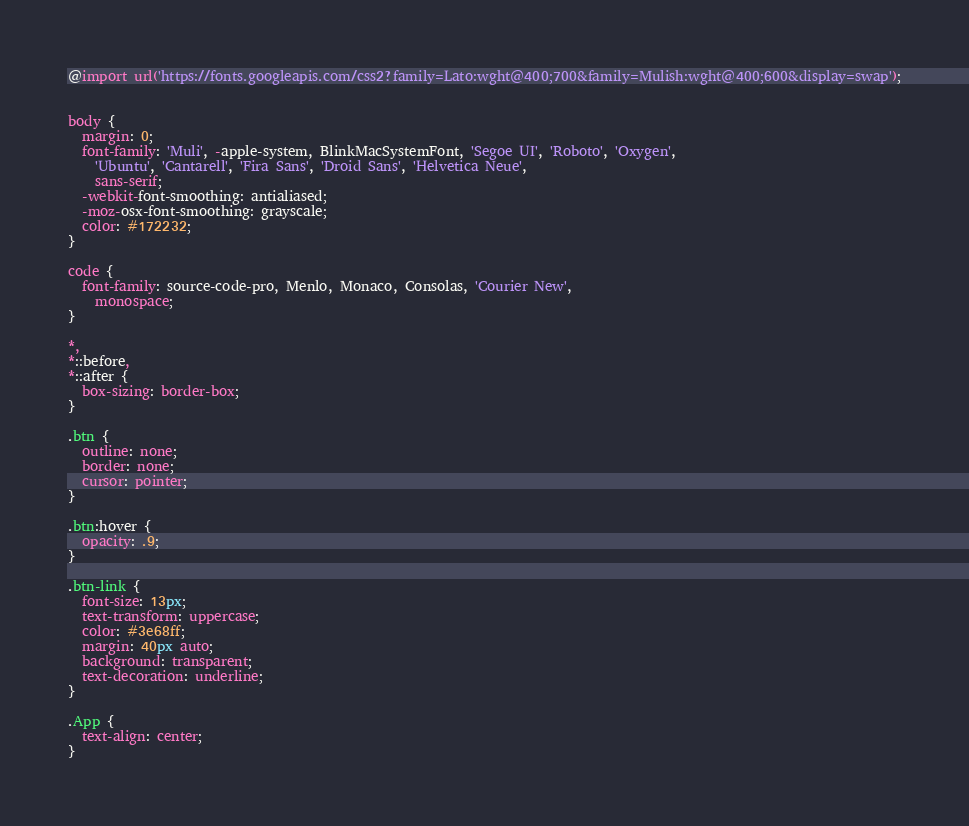Convert code to text. <code><loc_0><loc_0><loc_500><loc_500><_CSS_>@import url('https://fonts.googleapis.com/css2?family=Lato:wght@400;700&family=Mulish:wght@400;600&display=swap');


body {
  margin: 0;
  font-family: 'Muli', -apple-system, BlinkMacSystemFont, 'Segoe UI', 'Roboto', 'Oxygen',
    'Ubuntu', 'Cantarell', 'Fira Sans', 'Droid Sans', 'Helvetica Neue',
    sans-serif;
  -webkit-font-smoothing: antialiased;
  -moz-osx-font-smoothing: grayscale;
  color: #172232;
}

code {
  font-family: source-code-pro, Menlo, Monaco, Consolas, 'Courier New',
    monospace;
}

*,
*::before,
*::after {
  box-sizing: border-box;
}

.btn {
  outline: none;
  border: none;
  cursor: pointer;
}

.btn:hover {
  opacity: .9;
}

.btn-link {
  font-size: 13px;
  text-transform: uppercase;
  color: #3e68ff;
  margin: 40px auto;
  background: transparent;
  text-decoration: underline;
}

.App {
  text-align: center;
}
</code> 